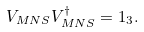Convert formula to latex. <formula><loc_0><loc_0><loc_500><loc_500>V _ { M N S } V _ { M N S } ^ { \dagger } = { 1 _ { 3 } } .</formula> 